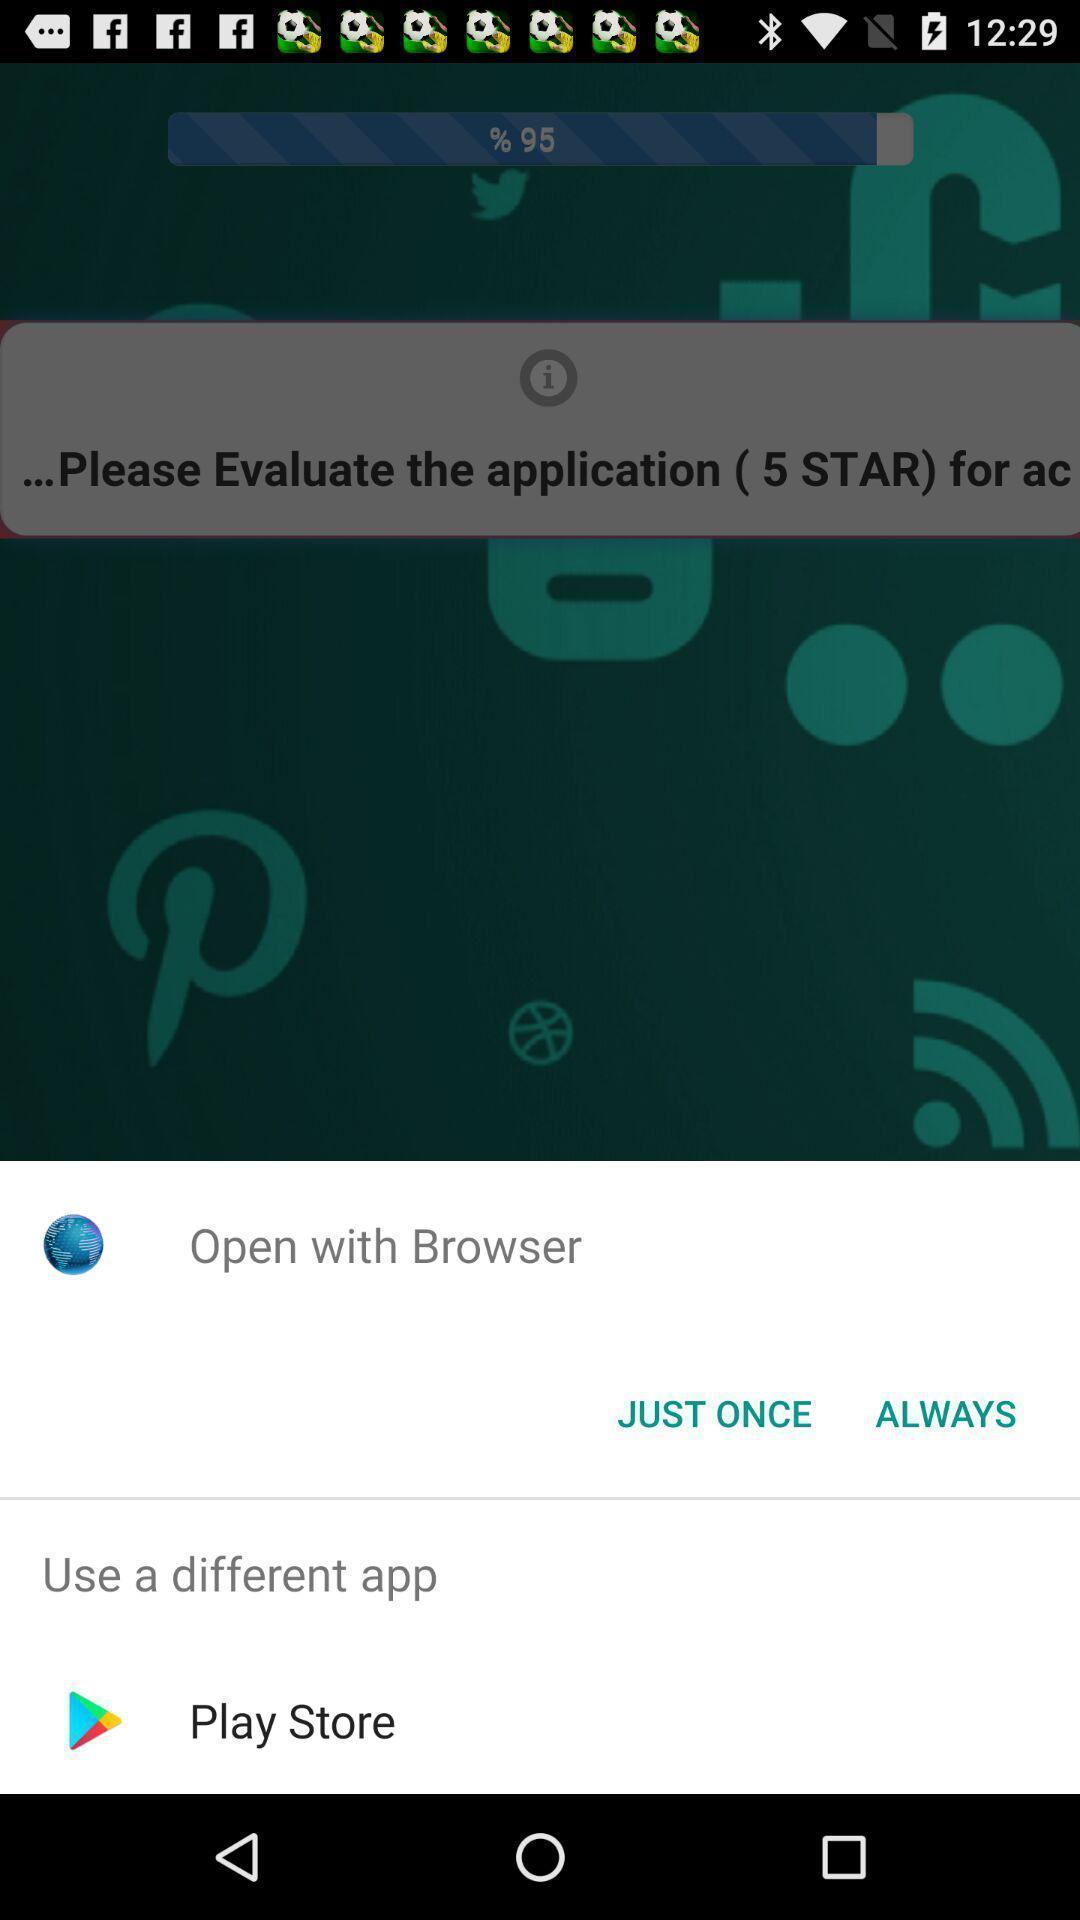What details can you identify in this image? Pop-up shows to open with browser. 